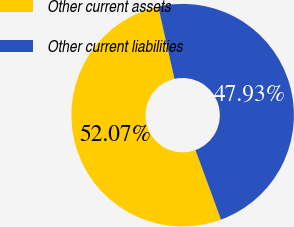Convert chart. <chart><loc_0><loc_0><loc_500><loc_500><pie_chart><fcel>Other current assets<fcel>Other current liabilities<nl><fcel>52.07%<fcel>47.93%<nl></chart> 